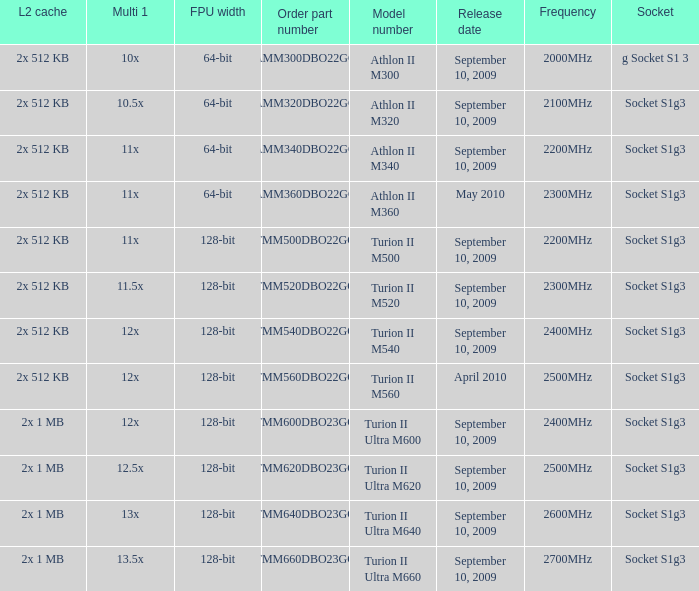Would you mind parsing the complete table? {'header': ['L2 cache', 'Multi 1', 'FPU width', 'Order part number', 'Model number', 'Release date', 'Frequency', 'Socket'], 'rows': [['2x 512 KB', '10x', '64-bit', 'AMM300DBO22GQ', 'Athlon II M300', 'September 10, 2009', '2000MHz', 'g Socket S1 3'], ['2x 512 KB', '10.5x', '64-bit', 'AMM320DBO22GQ', 'Athlon II M320', 'September 10, 2009', '2100MHz', 'Socket S1g3'], ['2x 512 KB', '11x', '64-bit', 'AMM340DBO22GQ', 'Athlon II M340', 'September 10, 2009', '2200MHz', 'Socket S1g3'], ['2x 512 KB', '11x', '64-bit', 'AMM360DBO22GQ', 'Athlon II M360', 'May 2010', '2300MHz', 'Socket S1g3'], ['2x 512 KB', '11x', '128-bit', 'TMM500DBO22GQ', 'Turion II M500', 'September 10, 2009', '2200MHz', 'Socket S1g3'], ['2x 512 KB', '11.5x', '128-bit', 'TMM520DBO22GQ', 'Turion II M520', 'September 10, 2009', '2300MHz', 'Socket S1g3'], ['2x 512 KB', '12x', '128-bit', 'TMM540DBO22GQ', 'Turion II M540', 'September 10, 2009', '2400MHz', 'Socket S1g3'], ['2x 512 KB', '12x', '128-bit', 'TMM560DBO22GQ', 'Turion II M560', 'April 2010', '2500MHz', 'Socket S1g3'], ['2x 1 MB', '12x', '128-bit', 'TMM600DBO23GQ', 'Turion II Ultra M600', 'September 10, 2009', '2400MHz', 'Socket S1g3'], ['2x 1 MB', '12.5x', '128-bit', 'TMM620DBO23GQ', 'Turion II Ultra M620', 'September 10, 2009', '2500MHz', 'Socket S1g3'], ['2x 1 MB', '13x', '128-bit', 'TMM640DBO23GQ', 'Turion II Ultra M640', 'September 10, 2009', '2600MHz', 'Socket S1g3'], ['2x 1 MB', '13.5x', '128-bit', 'TMM660DBO23GQ', 'Turion II Ultra M660', 'September 10, 2009', '2700MHz', 'Socket S1g3']]} What is the socket with an order part number of amm300dbo22gq and a September 10, 2009 release date? G socket s1 3. 